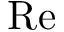Convert formula to latex. <formula><loc_0><loc_0><loc_500><loc_500>R e</formula> 